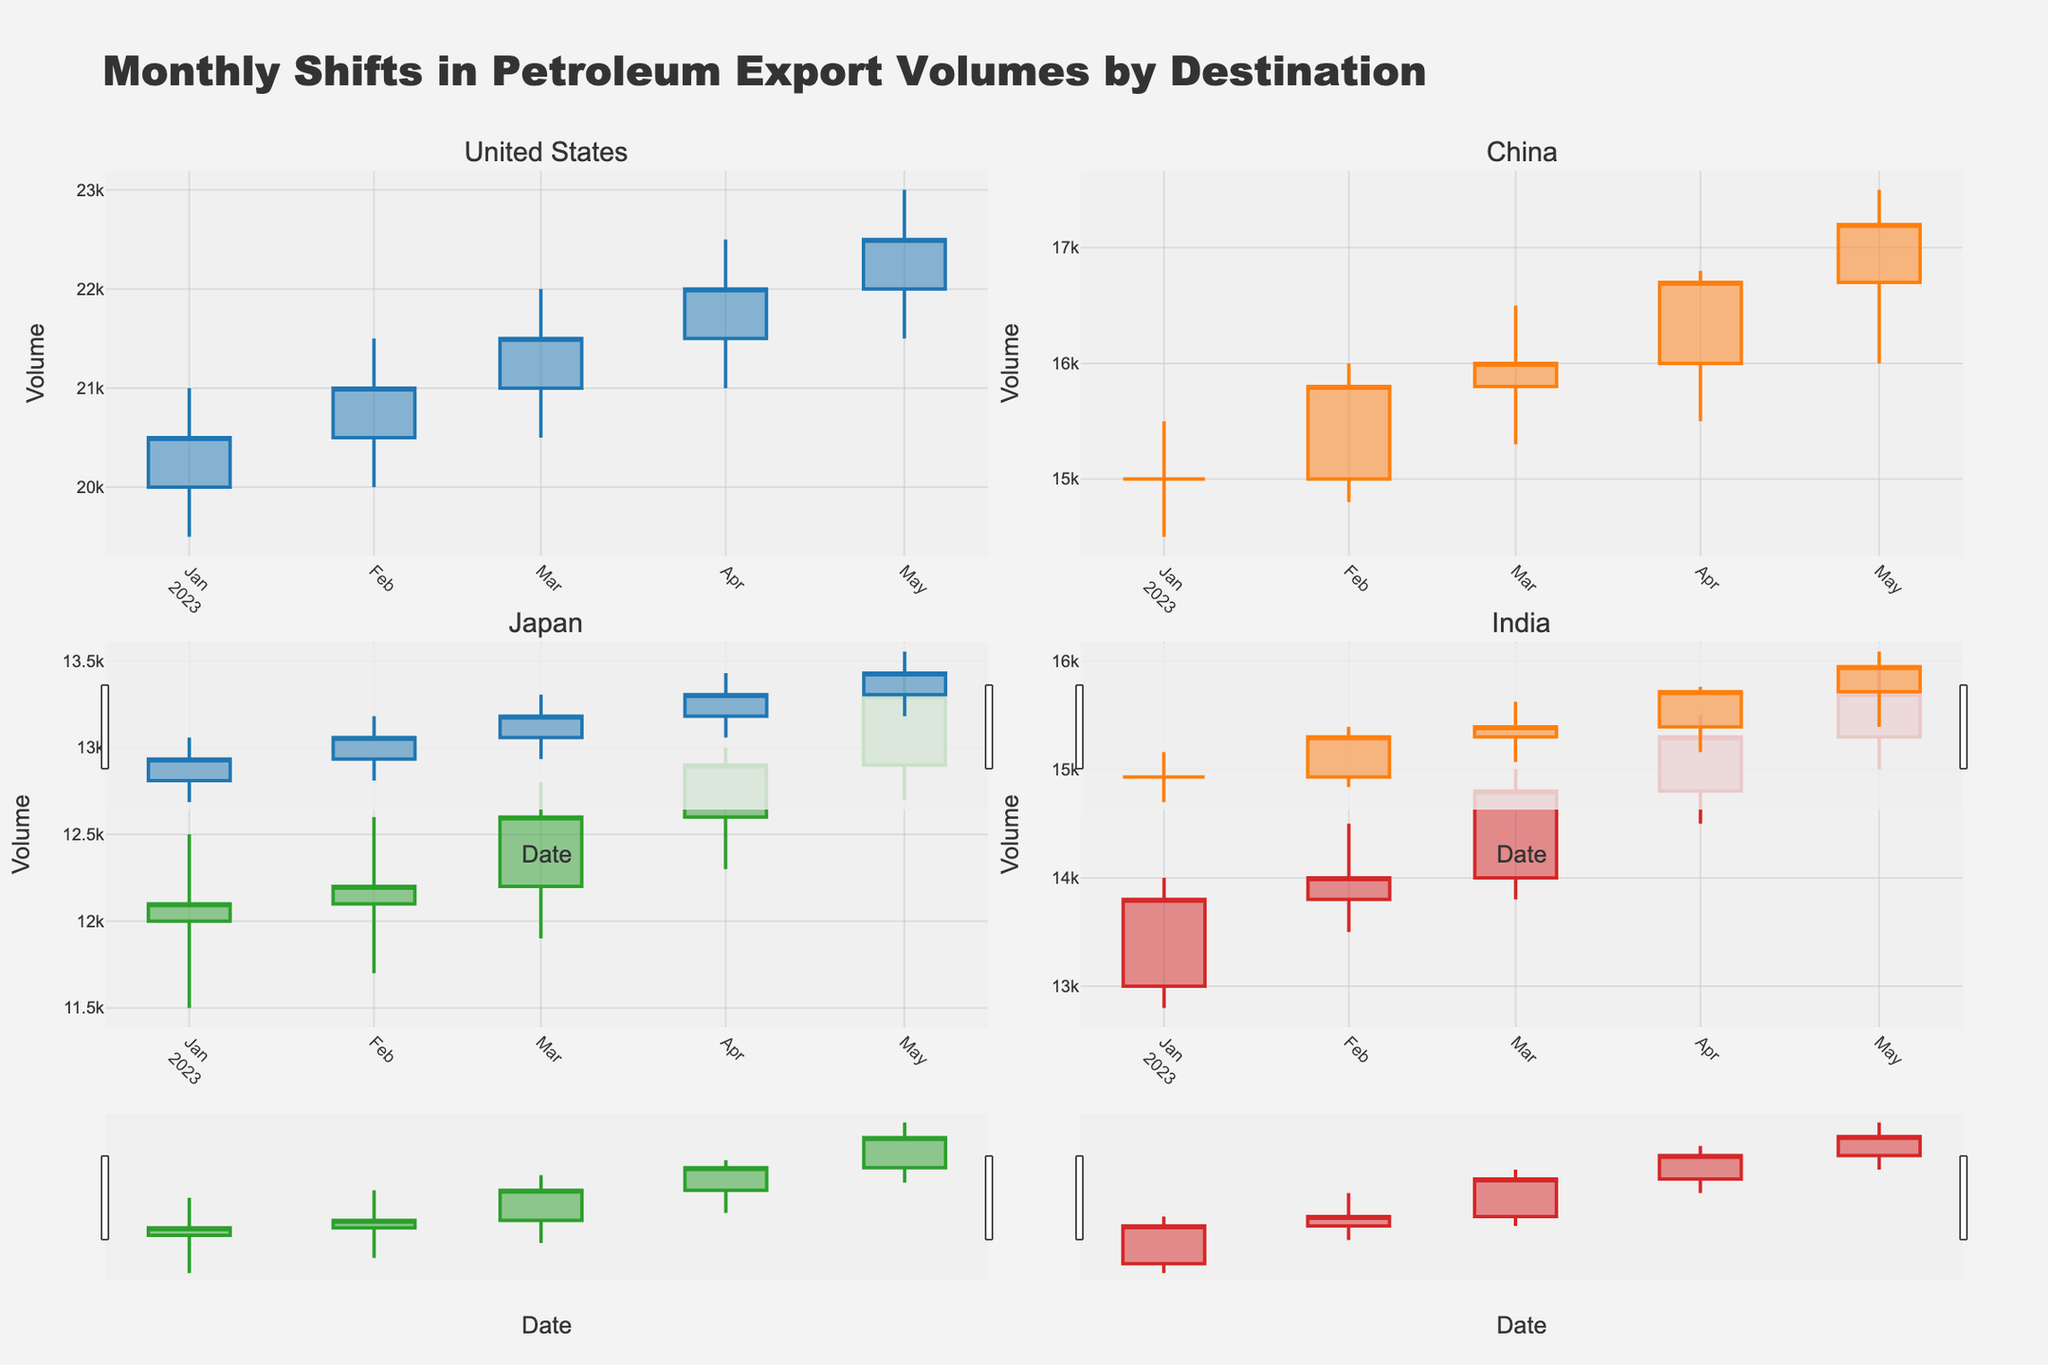What is the title of the figure? The title of the figure is prominently displayed at the top, reading "Monthly Shifts in Petroleum Export Volumes by Destination".
Answer: Monthly Shifts in Petroleum Export Volumes by Destination Which export destination had the highest volume in May 2023? By observing the final month of data for each export destination's candlestick, we see the highest "High" value in May 2023. For the United States, it is 23,000 which is the highest compared to China, Japan, and India.
Answer: United States How did the export volumes to Japan change from January to May 2023? By looking at the opening (January 2023: 12,000) and closing (May 2023: 13,300) values on the y-axis for Japan, you can determine the change in export volume.
Answer: Increased by 1,300 Which export destination had the most significant increase from open to close in April 2023? In April 2023, we compare the "Close" values to "Open" values for each destination: United States (22,000 - 21,500 = 500), China (16,700 - 16,000 = 700), Japan (12,900 - 12,600 = 300), India (15,300 - 14,800 = 500). China saw the greatest increase.
Answer: China Between February and March 2023, did China's export volume increase or decrease? Examining China's "Close" values from February 2023 (15,800) and March 2023 (16,000), we can see an increase.
Answer: Increase Which export destination shows the smallest fluctuation in export volumes over the entire period? To identify the smallest fluctuation, we observe the difference between "High" and "Low" values over time for each destination. Japan consistently shows smaller spreads compared to the others.
Answer: Japan What common trend can be seen among all export destinations from January to May 2023? All export destinations show an upward trend from January to May 2023, meaning each "Close" value in May is higher than in January.
Answer: Upward trend Did India have any months where the closing export volume was lower than the opening volume? Reviewing each month's candlestick for India, each "Close" is higher than the "Open" value within the plotted period. Thus, there were no months with a decrease in closing volume.
Answer: No Comparing March 2023 values, which export destination has a higher closing value: Japan or India? For March 2023, Japan's closing value is 12,600, and India's closing value is 14,800. India thus has the higher closing value.
Answer: India 